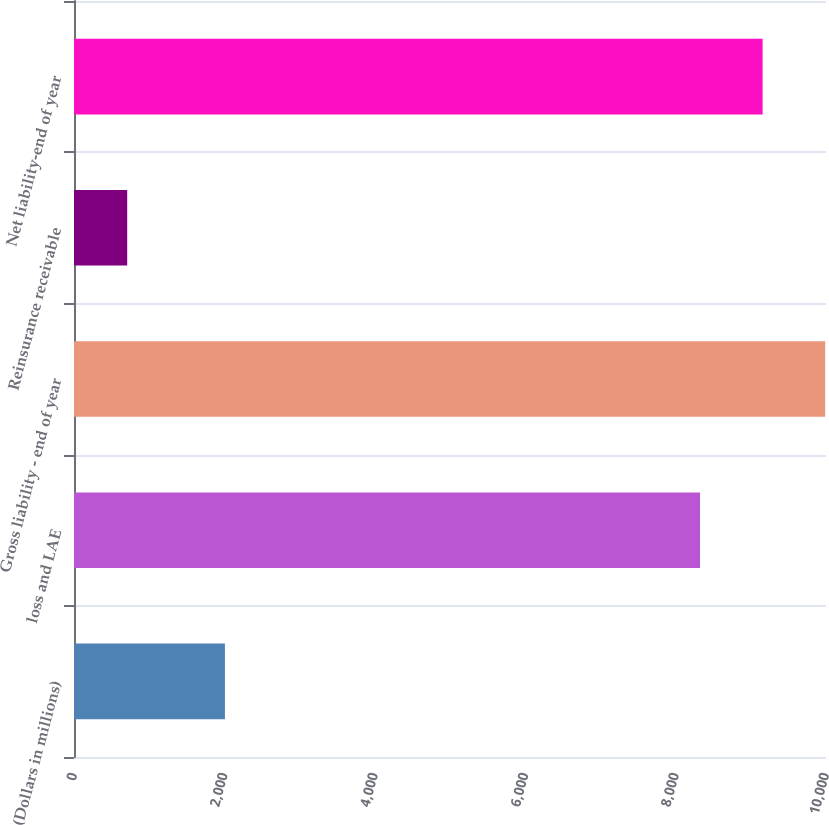<chart> <loc_0><loc_0><loc_500><loc_500><bar_chart><fcel>(Dollars in millions)<fcel>loss and LAE<fcel>Gross liability - end of year<fcel>Reinsurance receivable<fcel>Net liability-end of year<nl><fcel>2007<fcel>8324.7<fcel>9989.66<fcel>707.4<fcel>9157.18<nl></chart> 